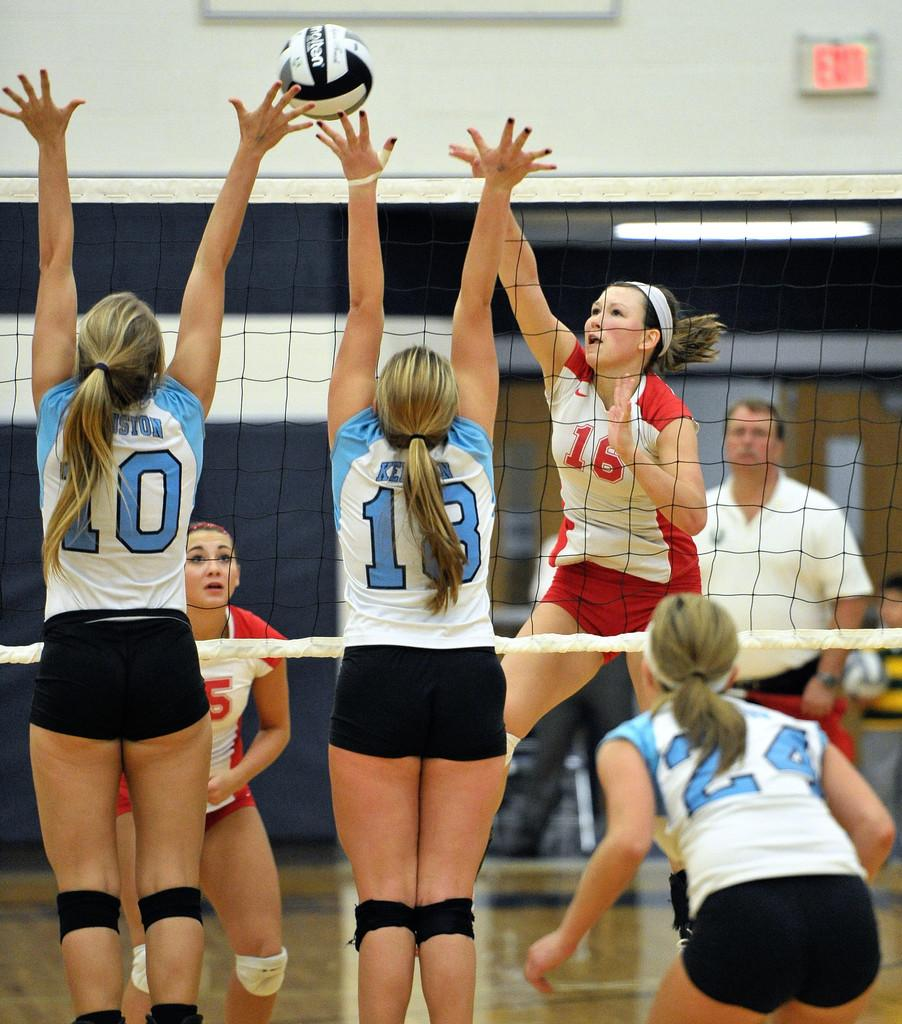<image>
Render a clear and concise summary of the photo. Girls playing volleyball with the numbers 10 and 18 about to hit the ball. 